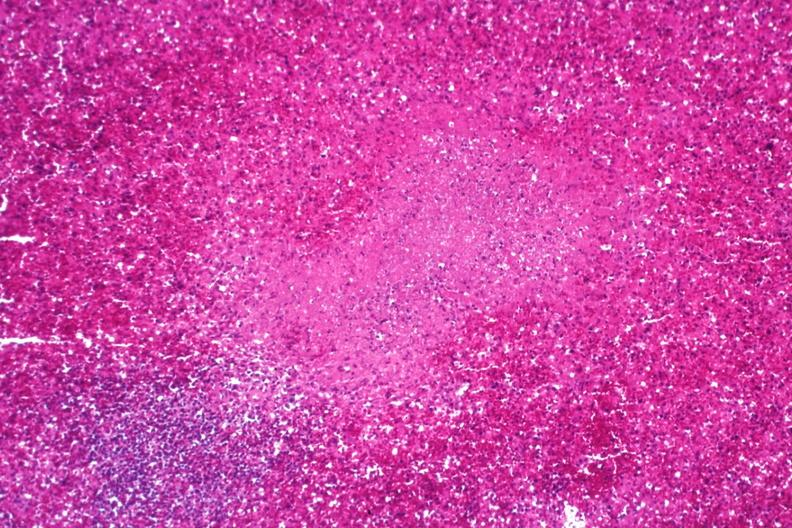what does this image show?
Answer the question using a single word or phrase. Necrotizing granuloma 